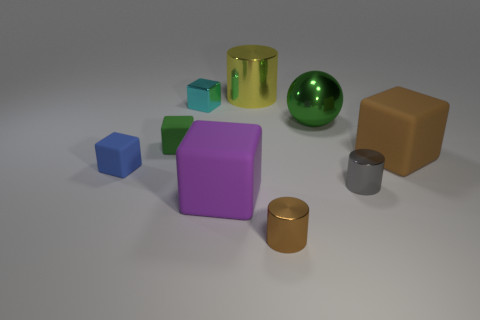Subtract all cyan cubes. How many cubes are left? 4 Subtract all metallic blocks. How many blocks are left? 4 Subtract all yellow cubes. Subtract all gray cylinders. How many cubes are left? 5 Add 1 tiny red shiny spheres. How many objects exist? 10 Subtract all balls. How many objects are left? 8 Add 7 tiny gray metallic objects. How many tiny gray metallic objects are left? 8 Add 7 small gray cylinders. How many small gray cylinders exist? 8 Subtract 0 cyan cylinders. How many objects are left? 9 Subtract all big things. Subtract all cyan objects. How many objects are left? 4 